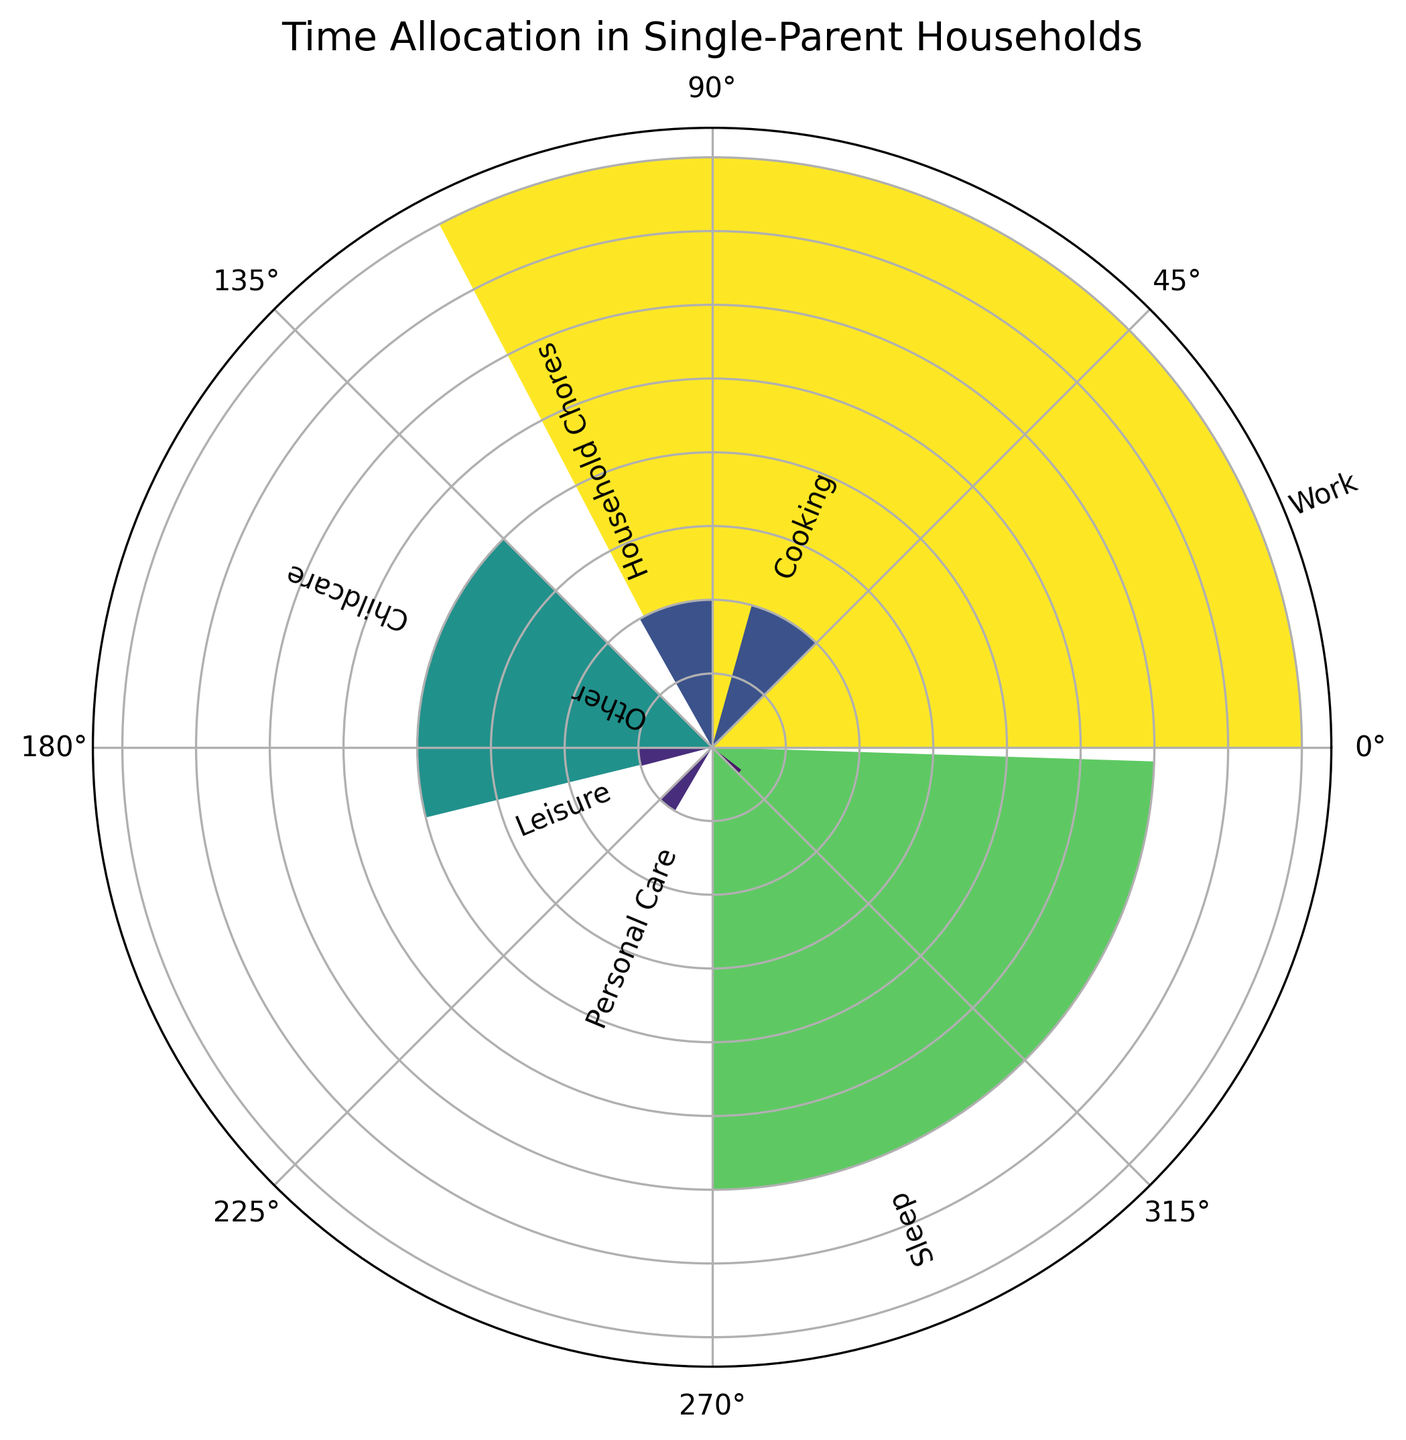What is the total time spent on household chores and childcare? Add the hours spent on household chores (2 hours) and childcare (4 hours): 2 + 4 = 6 hours.
Answer: 6 hours Which activity takes the most time in a single parent's day? Identify the activity with the longest bar. Work is visibly the tallest bar indicating it's 8 hours.
Answer: Work How much more time is spent on sleep compared to leisure? Subtract the hours spent on leisure (1 hour) from the hours spent on sleep (6 hours): 6 - 1 = 5 hours.
Answer: 5 hours What activities cumulatively occupy half of a single parent's day? Calculate half of 24 hours, which is 12 hours. Add activities in descending order of their time until the sum reaches 12 hours.
Work (8 hours) + childcare (4 hours) = 12 hours.
Answer: Work and Childcare What is the average time spent on cooking and personal care? Add the hours spent on cooking (2 hours) and personal care (1 hour), then divide by 2: (2 + 1) / 2 = 1.5 hours.
Answer: 1.5 hours Which activity occupies the smallest amount of time in the day? Identify the activity with the shortest bar. "Other" is the smallest wedge, at 0.5 hours.
Answer: Other How many hours are spent on activities other than work and sleep? Subtract the sum of hours spent on work and sleep from the total hours in a day: 24 - (8 + 6) = 10 hours.
Answer: 10 hours How much less time is spent on personal care compared to household chores? Subtract the hours spent on personal care (1 hour) from the hours spent on household chores (2 hours): 2 - 1 = 1 hour.
Answer: 1 hour 